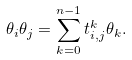Convert formula to latex. <formula><loc_0><loc_0><loc_500><loc_500>\theta _ { i } \theta _ { j } = \sum _ { k = 0 } ^ { n - 1 } t _ { i , j } ^ { k } \theta _ { k } .</formula> 